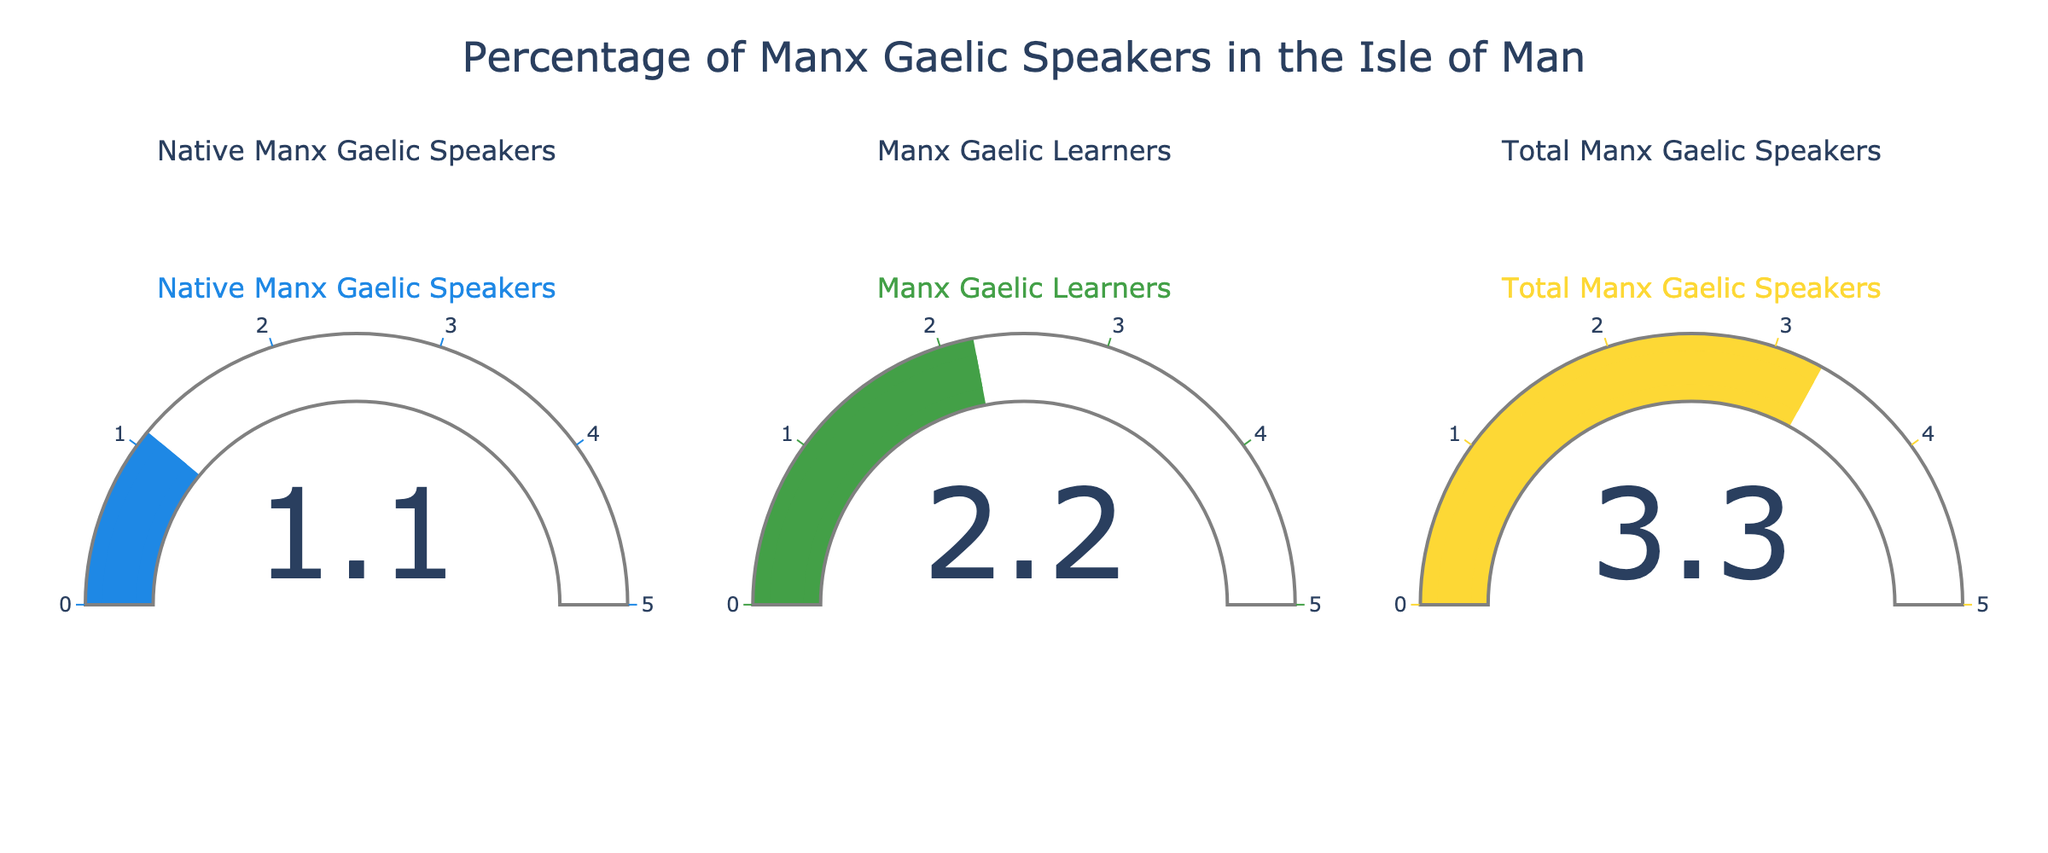What's the title of the figure? The title is located at the top center of the figure, and it reads "Percentage of Manx Gaelic Speakers in the Isle of Man".
Answer: Percentage of Manx Gaelic Speakers in the Isle of Man How many categories of Manx Gaelic speakers are shown in the figure? There are three gauge charts, each representing a different category as titled: Native Manx Gaelic Speakers, Manx Gaelic Learners, and Total Manx Gaelic Speakers.
Answer: 3 Which category has the highest percentage of speakers? By looking at the values displayed on each gauge, we see that Total Manx Gaelic Speakers has the highest percentage, which is 3.3%.
Answer: Total Manx Gaelic Speakers What is the percentage of Manx Gaelic learners? The percentage of Manx Gaelic learners is displayed on the second gauge chart, which shows 2.2%.
Answer: 2.2% What is the difference between the percentage of Total Manx Gaelic Speakers and Native Manx Gaelic Speakers? The percentage of Total Manx Gaelic Speakers is 3.3%, and the percentage of Native Manx Gaelic Speakers is 1.1%. The difference between them is calculated as 3.3% - 1.1%.
Answer: 2.2% What colors are used for the gauge representing Native Manx Gaelic Speakers? The gauge for Native Manx Gaelic Speakers is the first one, which uses a blue color for the gauge elements.
Answer: Blue Compare the percentage of Native Manx Gaelic Speakers to Manx Gaelic Learners. Which is higher and by how much? The percentage of Native Manx Gaelic Speakers is 1.1%, and the percentage of Manx Gaelic Learners is 2.2%. We calculate the difference by subtracting 1.1% from 2.2%, finding that Manx Gaelic Learners is higher by 1.1%.
Answer: Manx Gaelic Learners is higher by 1.1% What is the average percentage of all three categories? To find the average, we add the percentages of all three categories: 1.1% + 2.2% + 3.3% = 6.6%. Then, we divide by the number of categories, which is 3. The average is 6.6% / 3 = 2.2%.
Answer: 2.2% What is the range of the gauges in the figure? Observing the scales on each gauge, we see that they all have an axis range from 0 to 5.
Answer: 0 to 5 